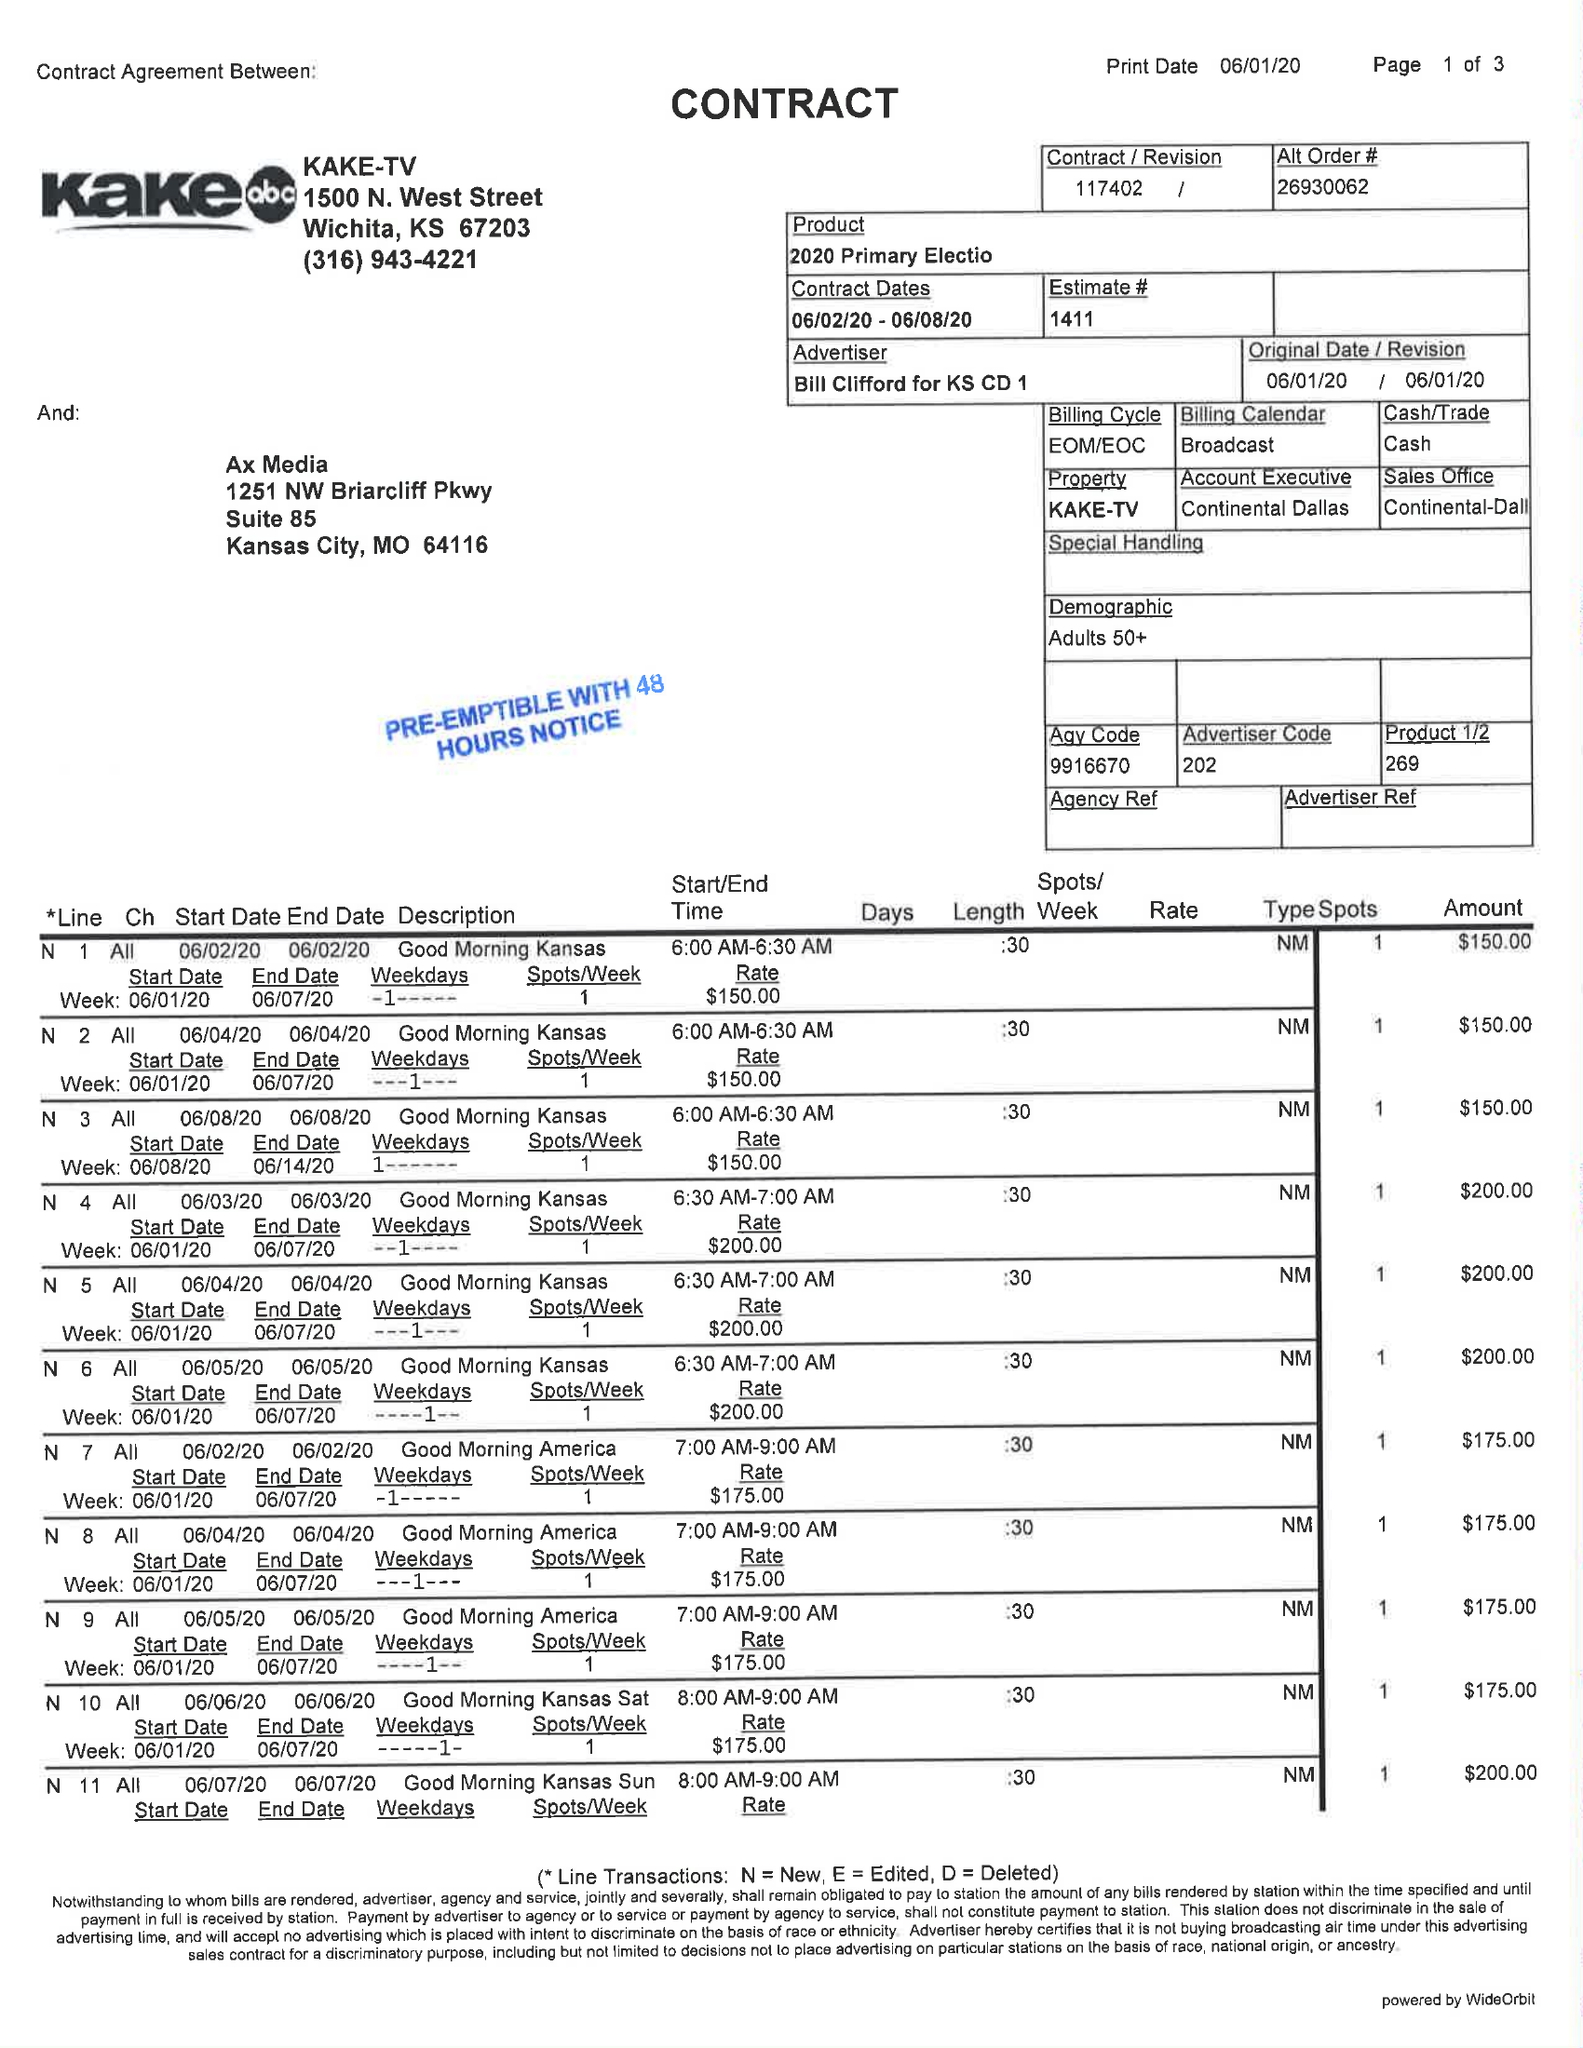What is the value for the flight_from?
Answer the question using a single word or phrase. 06/02/20 